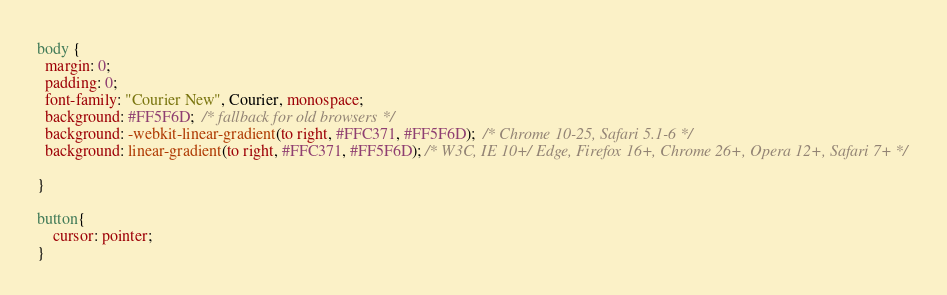Convert code to text. <code><loc_0><loc_0><loc_500><loc_500><_CSS_>body {
  margin: 0;
  padding: 0;
  font-family: "Courier New", Courier, monospace;
  background: #FF5F6D;  /* fallback for old browsers */
  background: -webkit-linear-gradient(to right, #FFC371, #FF5F6D);  /* Chrome 10-25, Safari 5.1-6 */
  background: linear-gradient(to right, #FFC371, #FF5F6D); /* W3C, IE 10+/ Edge, Firefox 16+, Chrome 26+, Opera 12+, Safari 7+ */

}

button{
    cursor: pointer;
}</code> 